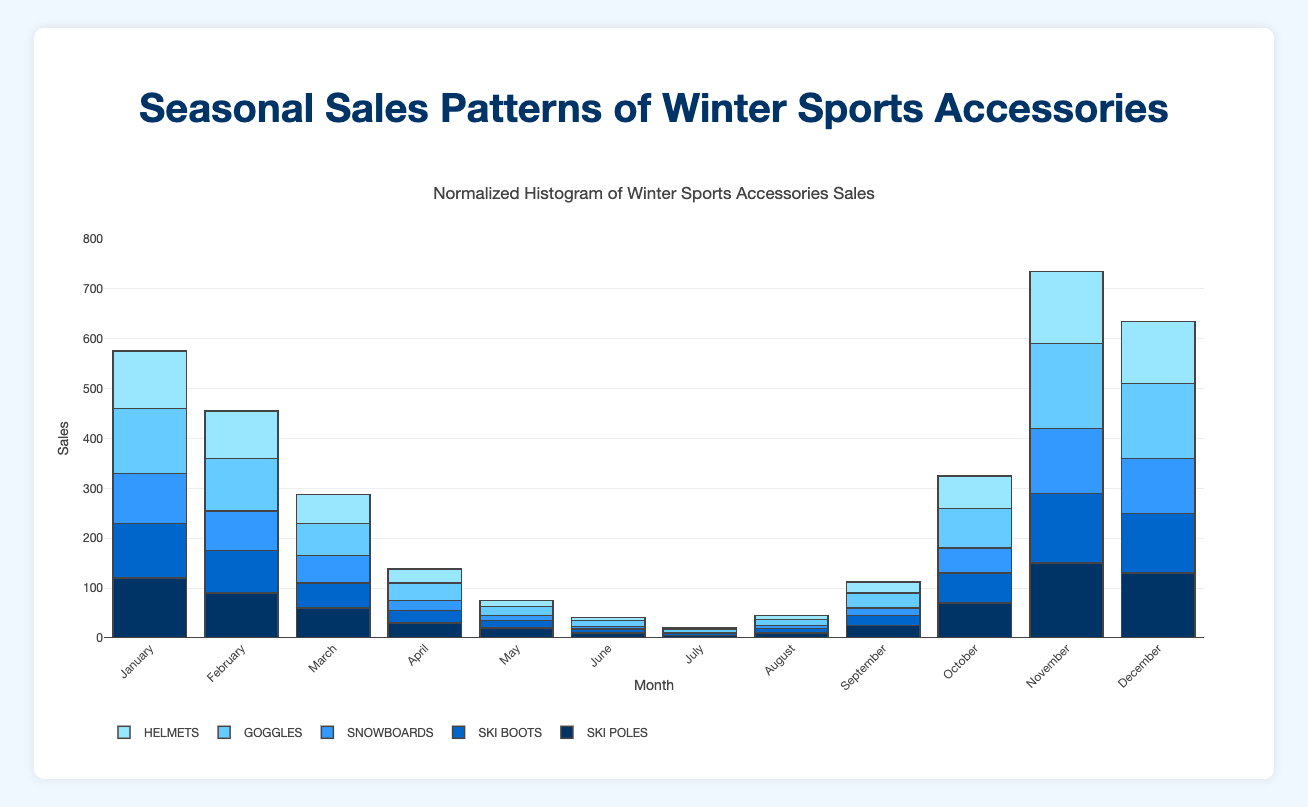What's the title of the figure? The title is at the top of the figure and is displayed prominently in large font.
Answer: Normalized Histogram of Winter Sports Accessories Sales During which month were the sales of goggles the highest? By looking at the height of the bars for goggles, which are colored differently, we can see that they reach their maximum in December.
Answer: December Which accessory had the lowest sales in July? By comparing all the bar heights for each accessory in July, we find that snowboards have the shortest bar.
Answer: Snowboards What's the sum of sales for ski poles and ski boots in January? To find the sum, add the January sales for ski poles (120) and ski boots (110) together: 120 + 110.
Answer: 230 Which month saw equal sales for helmets and goggles? By analyzing the height of the bars for each month, we see that in February (both helmets and goggles) have the same height.
Answer: February How much higher were goggle sales in November compared to March? To calculate this, subtract the sales in March (65) for goggles from the sales in November (170): 170 - 65.
Answer: 105 What's the average monthly sales for snowboards from May to August? Sum the sales of snowboards from May (10), June (5), July (2), and August (6), then divide by the number of months (4): (10 + 5 + 2 + 6) / 4.
Answer: 5.75 Which month experienced the lowest total sales for all accessories combined? Sum the bar heights for each accessory per month and compare. April has the smallest combined bar heights.
Answer: April In which month do ski poles and ski boots sales differ the most? Calculate the differences in sales for each month and identify the maximum difference. December shows the greatest difference between ski poles (130) and ski boots (120).
Answer: December How do the sales patterns of helmets and ski boots compare over the year? By observing the figure, we notice that both have similar patterns with peaks and troughs occurring in the same months. Peaks in sales happen from November to January, a dip from March to September, and a gradual rise back again. Despite similarities, helmets tend to have slightly higher sales.
Answer: Comparable with slight differences 